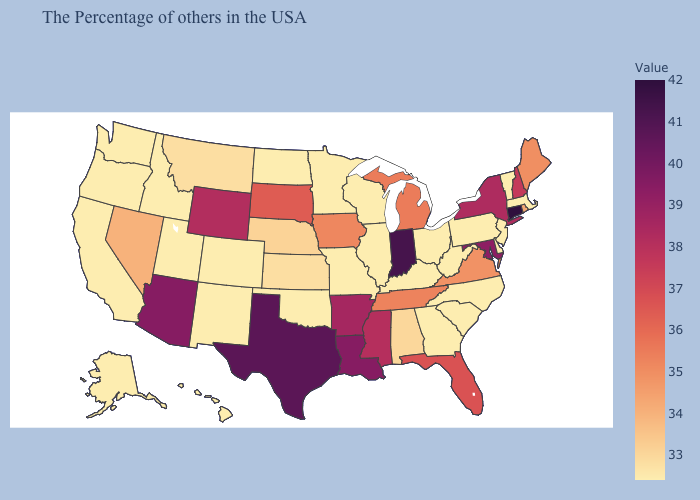Among the states that border Idaho , which have the highest value?
Quick response, please. Wyoming. Among the states that border Ohio , does Indiana have the highest value?
Short answer required. Yes. Which states have the highest value in the USA?
Concise answer only. Connecticut. 